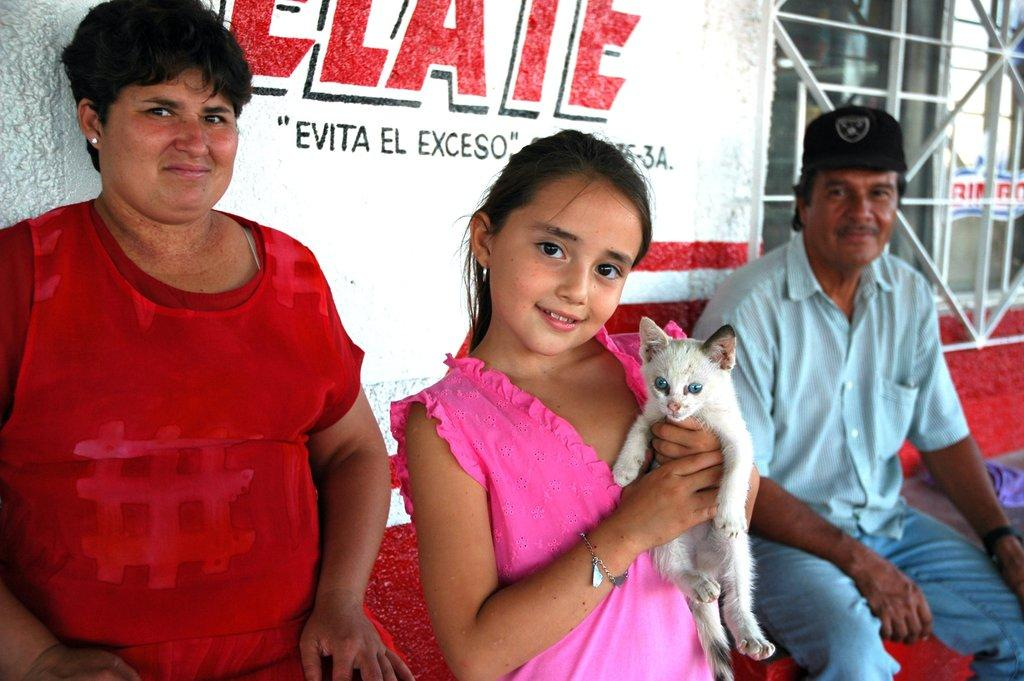How many people are in the image? There are three people in the image: a man, a woman, and a girl. What is the man wearing on his head? The man is wearing a cap. What expressions do the man and woman have? Both the man and the woman are smiling. What is the girl holding in her hand? The girl is holding a cat in her hand. What are the expressions of the girl and the woman? Both the girl and the woman are smiling. Can you tell me where the umbrella is located in the image? There is no umbrella present in the image. What type of boat is the girl riding in the image? There is no boat present in the image; the girl is holding a cat in her hand. 